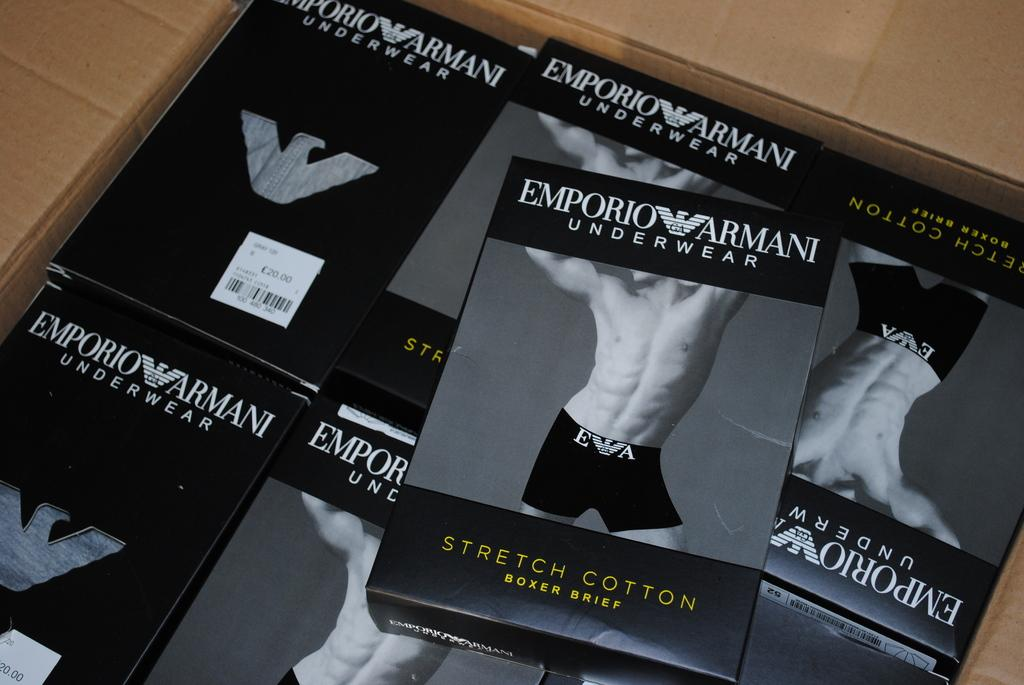<image>
Relay a brief, clear account of the picture shown. Several packs of Emporio Armani branded stretch cotton underwear. 